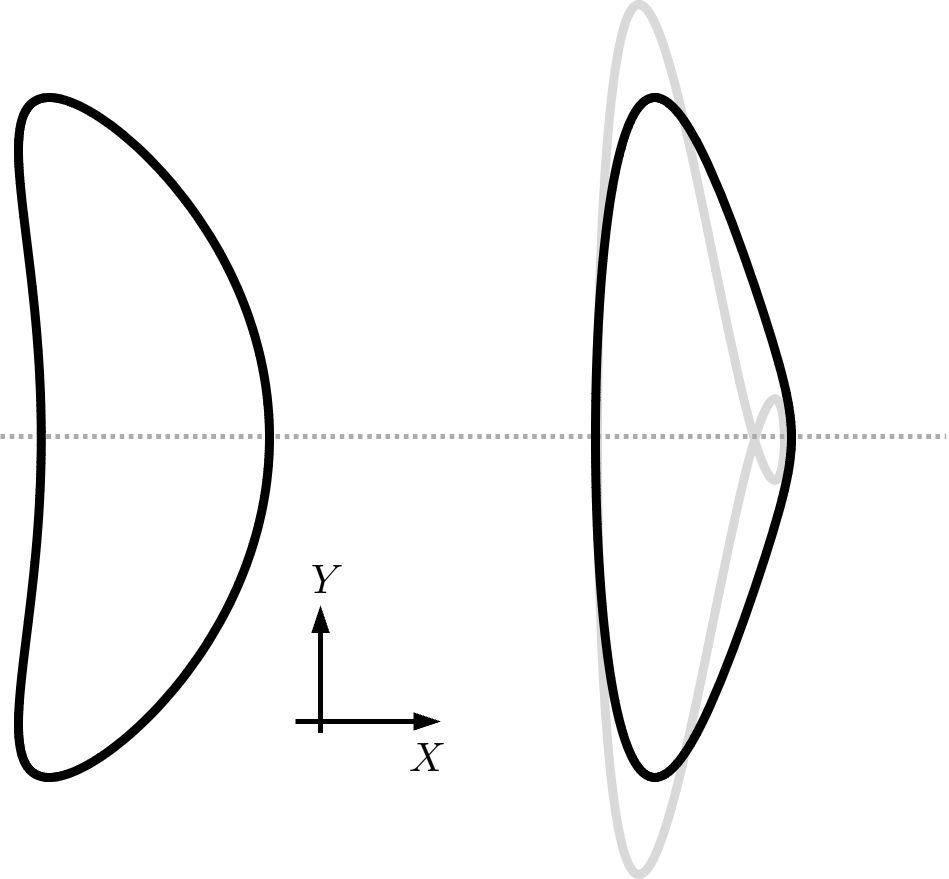How does the transformation affect the shape seen in the image regarding its symmetry? The transformation preserves the symmetry of the original shape. The image shows that the transformed shape retains its symmetrical properties about its central axis, indicating that the symmetry is consistent before and after the transformation. 